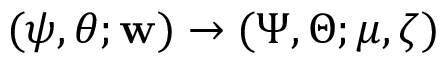<formula> <loc_0><loc_0><loc_500><loc_500>( \psi , \theta ; { w } ) \rightarrow ( \Psi , \Theta ; \mu , \zeta )</formula> 